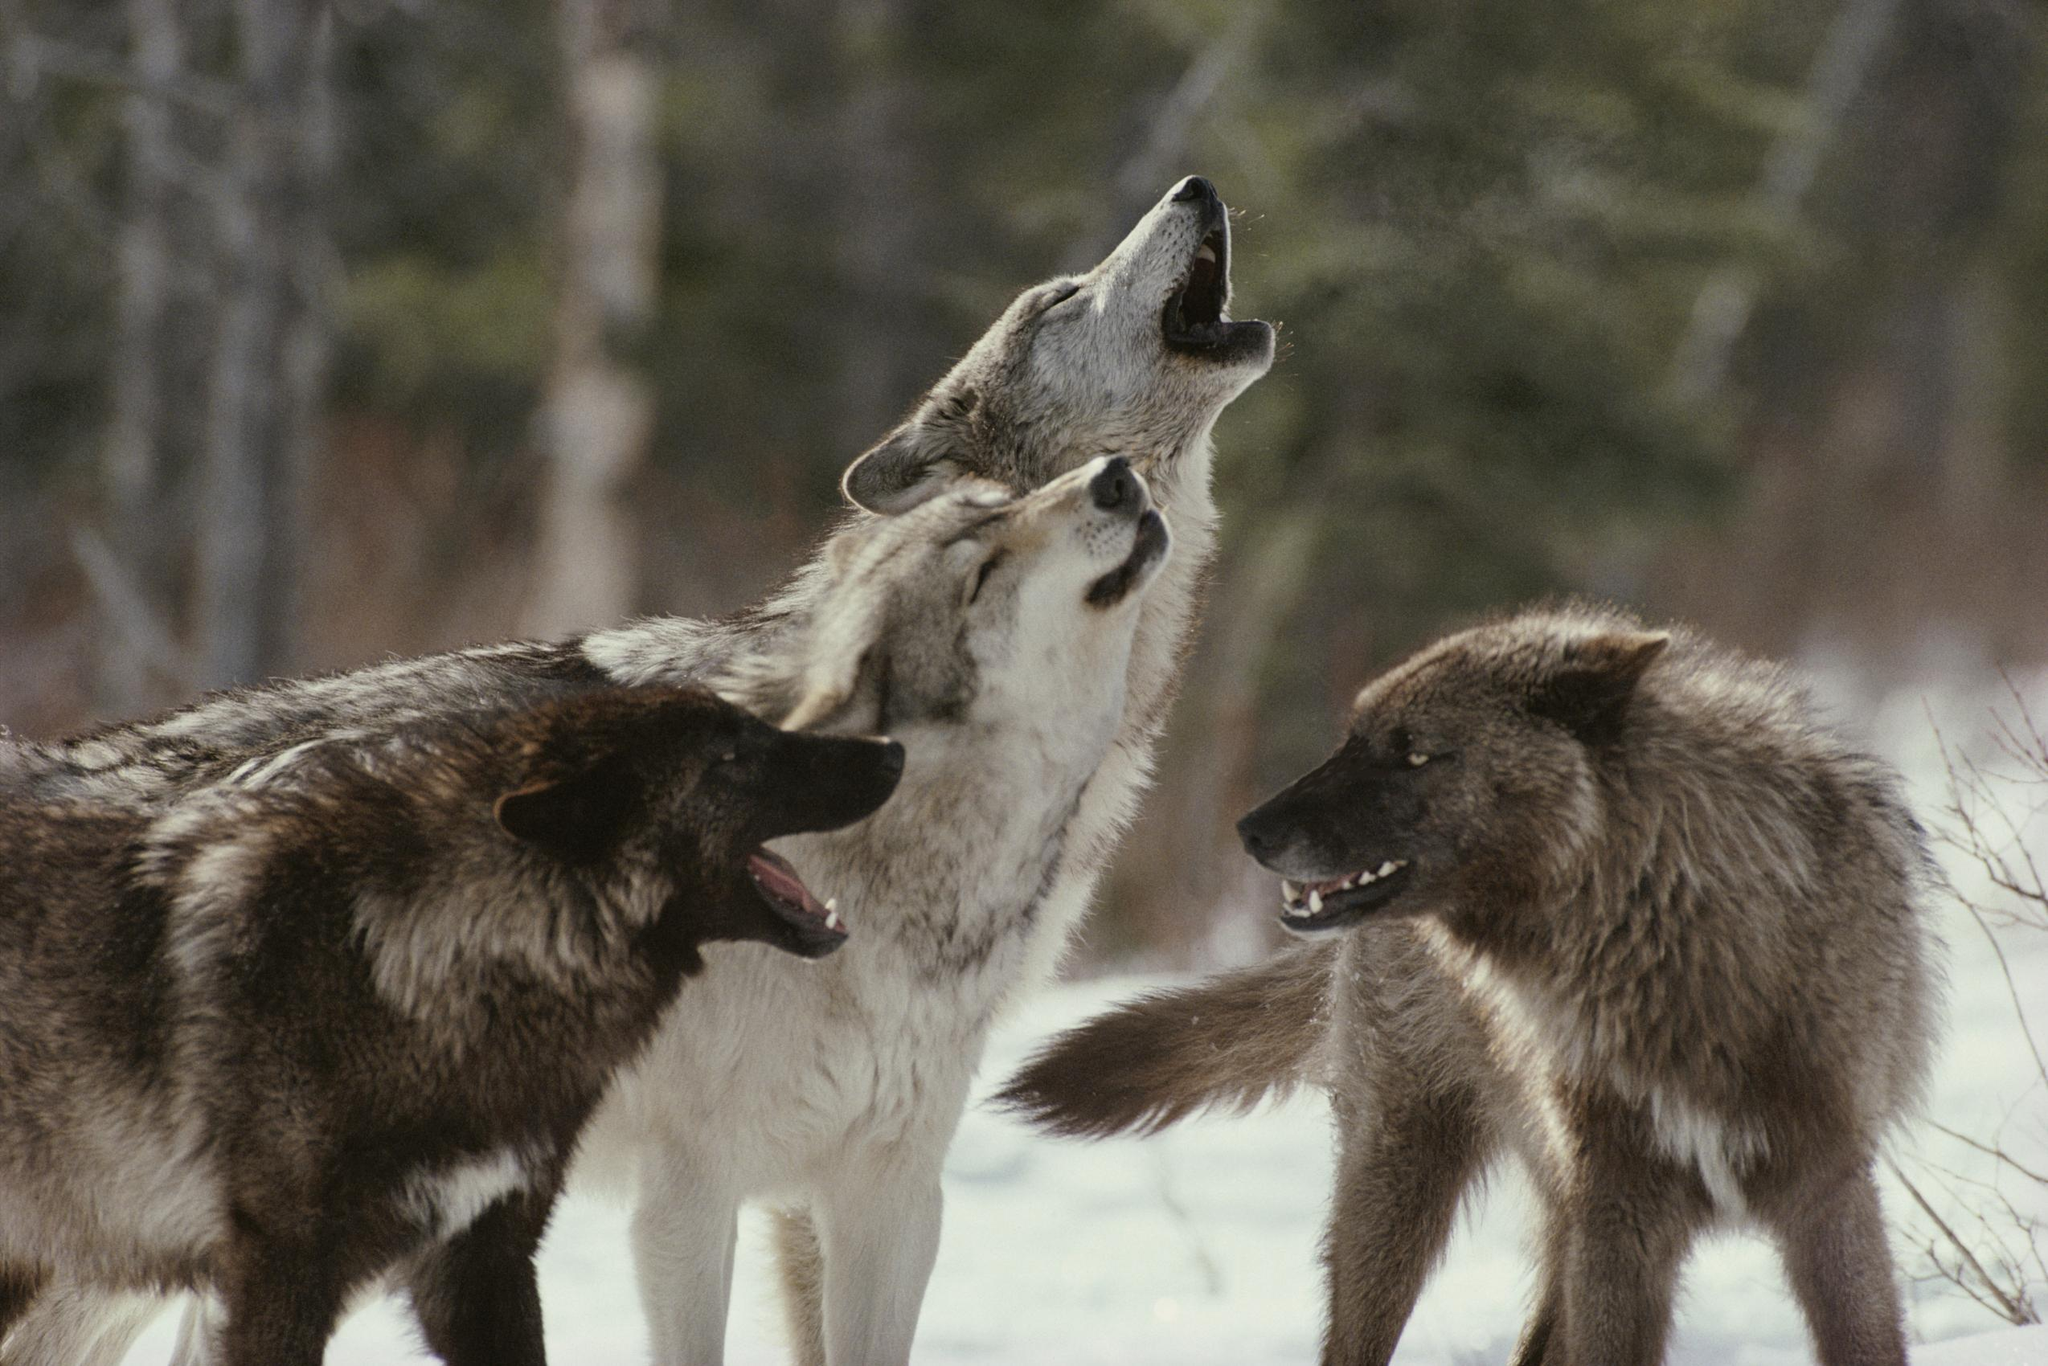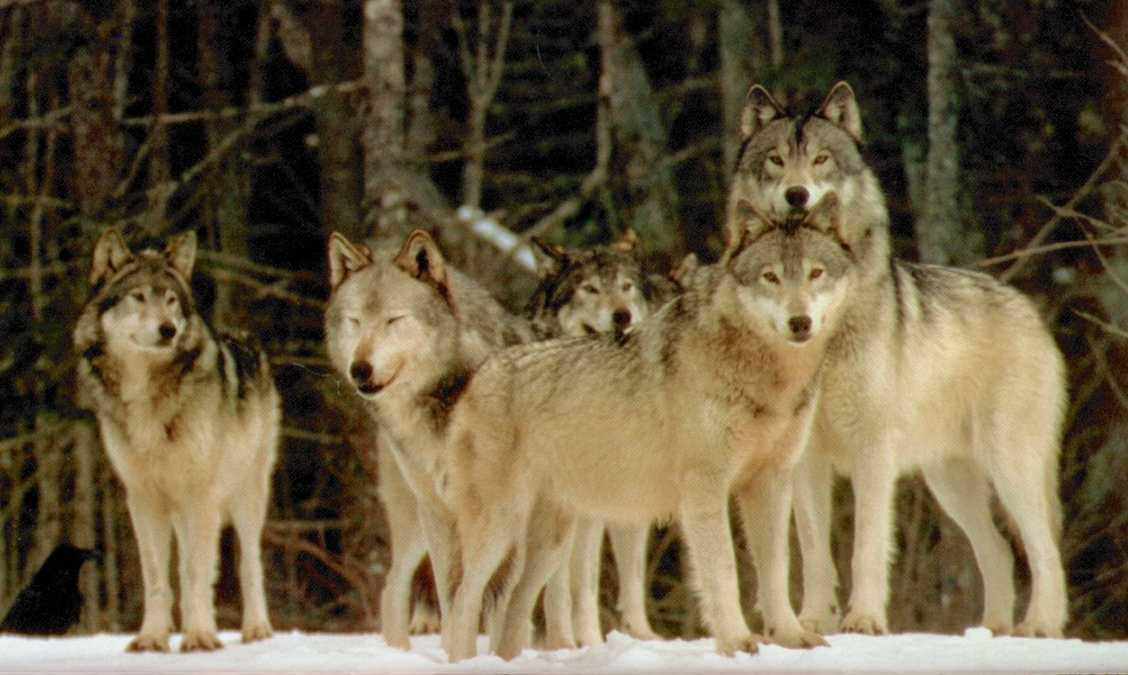The first image is the image on the left, the second image is the image on the right. Evaluate the accuracy of this statement regarding the images: "One image contains only non-howling wolves with non-raised heads, and the other image includes wolves howling with raised heads.". Is it true? Answer yes or no. Yes. The first image is the image on the left, the second image is the image on the right. Considering the images on both sides, is "The right image contains five wolves." valid? Answer yes or no. Yes. 